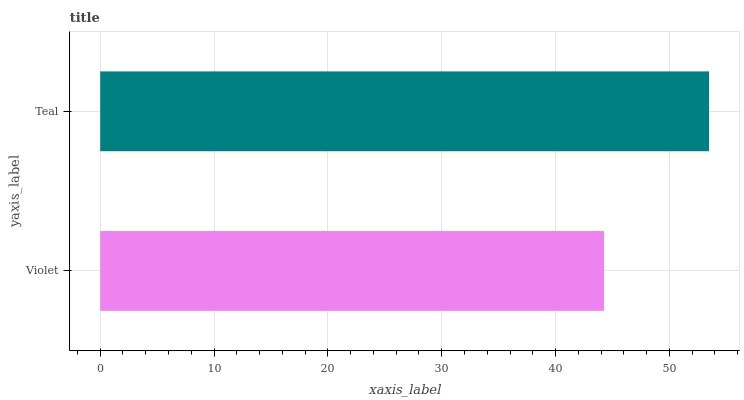Is Violet the minimum?
Answer yes or no. Yes. Is Teal the maximum?
Answer yes or no. Yes. Is Teal the minimum?
Answer yes or no. No. Is Teal greater than Violet?
Answer yes or no. Yes. Is Violet less than Teal?
Answer yes or no. Yes. Is Violet greater than Teal?
Answer yes or no. No. Is Teal less than Violet?
Answer yes or no. No. Is Teal the high median?
Answer yes or no. Yes. Is Violet the low median?
Answer yes or no. Yes. Is Violet the high median?
Answer yes or no. No. Is Teal the low median?
Answer yes or no. No. 